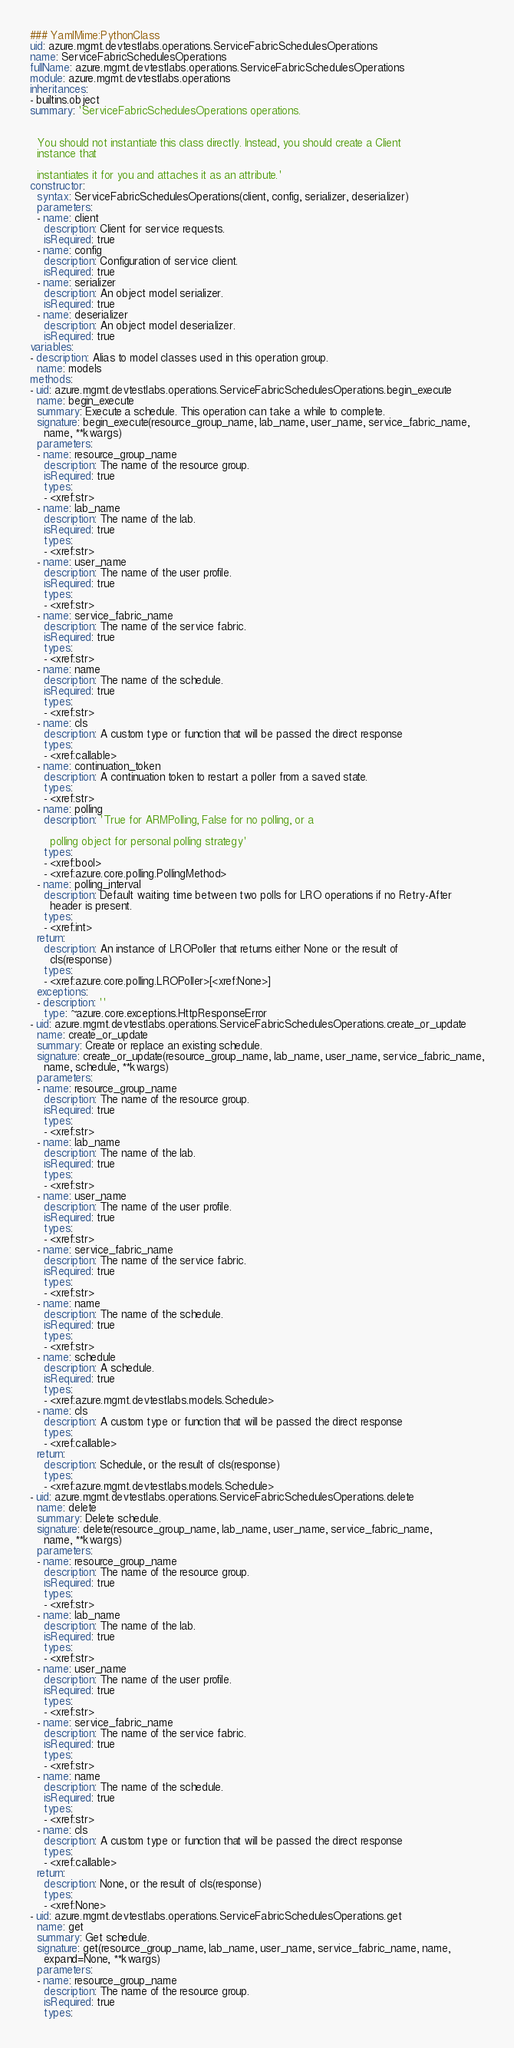Convert code to text. <code><loc_0><loc_0><loc_500><loc_500><_YAML_>### YamlMime:PythonClass
uid: azure.mgmt.devtestlabs.operations.ServiceFabricSchedulesOperations
name: ServiceFabricSchedulesOperations
fullName: azure.mgmt.devtestlabs.operations.ServiceFabricSchedulesOperations
module: azure.mgmt.devtestlabs.operations
inheritances:
- builtins.object
summary: 'ServiceFabricSchedulesOperations operations.


  You should not instantiate this class directly. Instead, you should create a Client
  instance that

  instantiates it for you and attaches it as an attribute.'
constructor:
  syntax: ServiceFabricSchedulesOperations(client, config, serializer, deserializer)
  parameters:
  - name: client
    description: Client for service requests.
    isRequired: true
  - name: config
    description: Configuration of service client.
    isRequired: true
  - name: serializer
    description: An object model serializer.
    isRequired: true
  - name: deserializer
    description: An object model deserializer.
    isRequired: true
variables:
- description: Alias to model classes used in this operation group.
  name: models
methods:
- uid: azure.mgmt.devtestlabs.operations.ServiceFabricSchedulesOperations.begin_execute
  name: begin_execute
  summary: Execute a schedule. This operation can take a while to complete.
  signature: begin_execute(resource_group_name, lab_name, user_name, service_fabric_name,
    name, **kwargs)
  parameters:
  - name: resource_group_name
    description: The name of the resource group.
    isRequired: true
    types:
    - <xref:str>
  - name: lab_name
    description: The name of the lab.
    isRequired: true
    types:
    - <xref:str>
  - name: user_name
    description: The name of the user profile.
    isRequired: true
    types:
    - <xref:str>
  - name: service_fabric_name
    description: The name of the service fabric.
    isRequired: true
    types:
    - <xref:str>
  - name: name
    description: The name of the schedule.
    isRequired: true
    types:
    - <xref:str>
  - name: cls
    description: A custom type or function that will be passed the direct response
    types:
    - <xref:callable>
  - name: continuation_token
    description: A continuation token to restart a poller from a saved state.
    types:
    - <xref:str>
  - name: polling
    description: 'True for ARMPolling, False for no polling, or a

      polling object for personal polling strategy'
    types:
    - <xref:bool>
    - <xref:azure.core.polling.PollingMethod>
  - name: polling_interval
    description: Default waiting time between two polls for LRO operations if no Retry-After
      header is present.
    types:
    - <xref:int>
  return:
    description: An instance of LROPoller that returns either None or the result of
      cls(response)
    types:
    - <xref:azure.core.polling.LROPoller>[<xref:None>]
  exceptions:
  - description: ''
    type: ~azure.core.exceptions.HttpResponseError
- uid: azure.mgmt.devtestlabs.operations.ServiceFabricSchedulesOperations.create_or_update
  name: create_or_update
  summary: Create or replace an existing schedule.
  signature: create_or_update(resource_group_name, lab_name, user_name, service_fabric_name,
    name, schedule, **kwargs)
  parameters:
  - name: resource_group_name
    description: The name of the resource group.
    isRequired: true
    types:
    - <xref:str>
  - name: lab_name
    description: The name of the lab.
    isRequired: true
    types:
    - <xref:str>
  - name: user_name
    description: The name of the user profile.
    isRequired: true
    types:
    - <xref:str>
  - name: service_fabric_name
    description: The name of the service fabric.
    isRequired: true
    types:
    - <xref:str>
  - name: name
    description: The name of the schedule.
    isRequired: true
    types:
    - <xref:str>
  - name: schedule
    description: A schedule.
    isRequired: true
    types:
    - <xref:azure.mgmt.devtestlabs.models.Schedule>
  - name: cls
    description: A custom type or function that will be passed the direct response
    types:
    - <xref:callable>
  return:
    description: Schedule, or the result of cls(response)
    types:
    - <xref:azure.mgmt.devtestlabs.models.Schedule>
- uid: azure.mgmt.devtestlabs.operations.ServiceFabricSchedulesOperations.delete
  name: delete
  summary: Delete schedule.
  signature: delete(resource_group_name, lab_name, user_name, service_fabric_name,
    name, **kwargs)
  parameters:
  - name: resource_group_name
    description: The name of the resource group.
    isRequired: true
    types:
    - <xref:str>
  - name: lab_name
    description: The name of the lab.
    isRequired: true
    types:
    - <xref:str>
  - name: user_name
    description: The name of the user profile.
    isRequired: true
    types:
    - <xref:str>
  - name: service_fabric_name
    description: The name of the service fabric.
    isRequired: true
    types:
    - <xref:str>
  - name: name
    description: The name of the schedule.
    isRequired: true
    types:
    - <xref:str>
  - name: cls
    description: A custom type or function that will be passed the direct response
    types:
    - <xref:callable>
  return:
    description: None, or the result of cls(response)
    types:
    - <xref:None>
- uid: azure.mgmt.devtestlabs.operations.ServiceFabricSchedulesOperations.get
  name: get
  summary: Get schedule.
  signature: get(resource_group_name, lab_name, user_name, service_fabric_name, name,
    expand=None, **kwargs)
  parameters:
  - name: resource_group_name
    description: The name of the resource group.
    isRequired: true
    types:</code> 